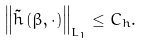Convert formula to latex. <formula><loc_0><loc_0><loc_500><loc_500>\left \| \tilde { h } \left ( \beta , \cdot \right ) \right \| _ { L _ { 1 } } \leq C _ { h } .</formula> 